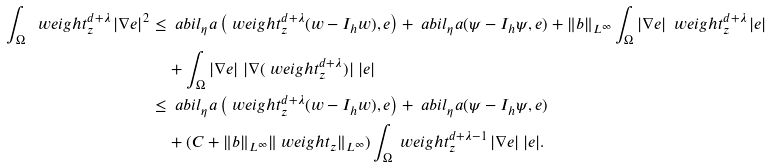<formula> <loc_0><loc_0><loc_500><loc_500>\int _ { \Omega } \ w e i g h t _ { z } ^ { d + \lambda } \, | \nabla e | ^ { 2 } & \leq \ a b i l _ { \eta } a \left ( \ w e i g h t _ { z } ^ { d + \lambda } ( w - I _ { h } w ) , e \right ) + \ a b i l _ { \eta } a ( \psi - I _ { h } \psi , e ) + \| b \| _ { L ^ { \infty } } \int _ { \Omega } | \nabla e | \, \ w e i g h t _ { z } ^ { d + \lambda } \, | e | \\ & \quad + \int _ { \Omega } | \nabla e | \ | \nabla ( \ w e i g h t _ { z } ^ { d + \lambda } ) | \ | e | \\ & \leq \ a b i l _ { \eta } a \left ( \ w e i g h t _ { z } ^ { d + \lambda } ( w - I _ { h } w ) , e \right ) + \ a b i l _ { \eta } a ( \psi - I _ { h } \psi , e ) \\ & \quad + ( C + \| b \| _ { L ^ { \infty } } \| \ w e i g h t _ { z } \| _ { L ^ { \infty } } ) \int _ { \Omega } \ w e i g h t _ { z } ^ { d + \lambda - 1 } \, | \nabla e | \, | e | .</formula> 